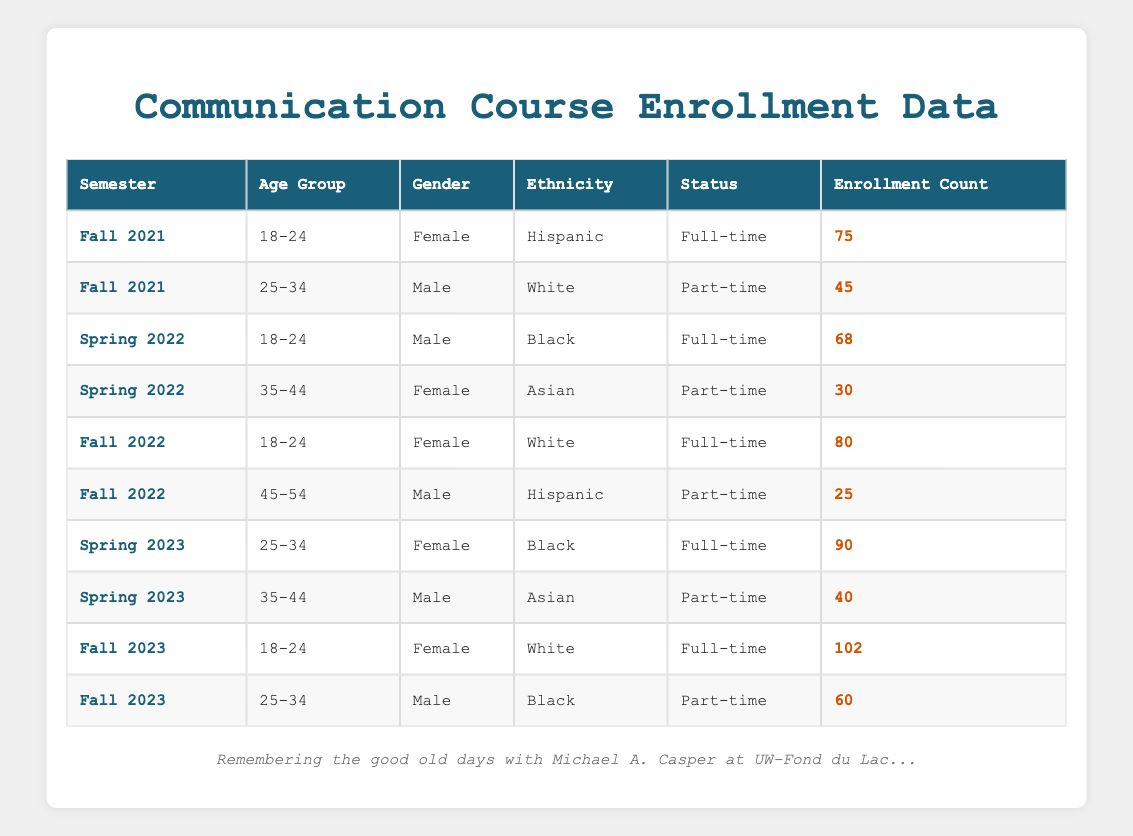What was the enrollment count for Female students in Fall 2021? In the table under the semester Fall 2021, I look for the row where the gender is Female. There is one such entry with an enrollment count of 75.
Answer: 75 What was the total enrollment count for Full-time students across all semesters? I will look for all entries in the table where the status is Full-time and sum their enrollment counts. The relevant counts are 75 (Fall 2021) + 68 (Spring 2022) + 80 (Fall 2022) + 90 (Spring 2023) + 102 (Fall 2023), which totals to 75 + 68 + 80 + 90 + 102 = 415.
Answer: 415 Is there an enrollment count for Male students aged 35-44 in Spring 2023? In Spring 2023, the table has a row for Male students aged 35-44, which shows an enrollment count of 40.
Answer: Yes What is the average enrollment count for Female students across all semesters? I will find all entries for Female students and then calculate their average. The relevant counts are 75 (Fall 2021), 80 (Fall 2022), 90 (Spring 2023), and 102 (Fall 2023), for a total of 75 + 80 + 90 + 102 = 347 across 4 entries. The average is 347 / 4 = 86.75.
Answer: 86.75 How many more Female full-time students enrolled in Fall 2023 compared to Fall 2021? I will look for the enrollment counts of Female full-time students for both semesters. Fall 2023 has 102 and Fall 2021 has 75. The difference is 102 - 75 = 27.
Answer: 27 What was the enrollment count for Hispanic Male students in Fall 2022? In the table, I look for Hispanic Male students in Fall 2022, which shows there is no entry, so the count is 0.
Answer: 0 Which semester had the highest enrollment count for Male students aged 25-34? I check the table for both Fall 2022 and Spring 2023, which include Male students aged 25-34. The counts are 0 for Fall 2022 and 90 for Spring 2023. Thus, Spring 2023 has the highest enrollment count of 90.
Answer: Spring 2023 What is the total enrollment count for Black students in Spring semesters? I identify the entries for Black students in Spring semesters, which are 68 (Spring 2022) and 90 (Spring 2023). The total is 68 + 90 = 158.
Answer: 158 Which demographic group had the least enrollment count in Fall 2022? I compare all enrollment counts in Fall 2022: 80 (Female, White) and 25 (Male, Hispanic). Therefore, the demographic group with the least enrollment is Male Students aged 45-54 with an enrollment count of 25.
Answer: Male Students aged 45-54 What was the total enrollment count for students aged 18-24 across all semesters? I find the enrollment counts for students aged 18-24 in each relevant semester: 75 (Fall 2021), 80 (Fall 2022), and 102 (Fall 2023). Adding them gives 75 + 80 + 102 = 257.
Answer: 257 